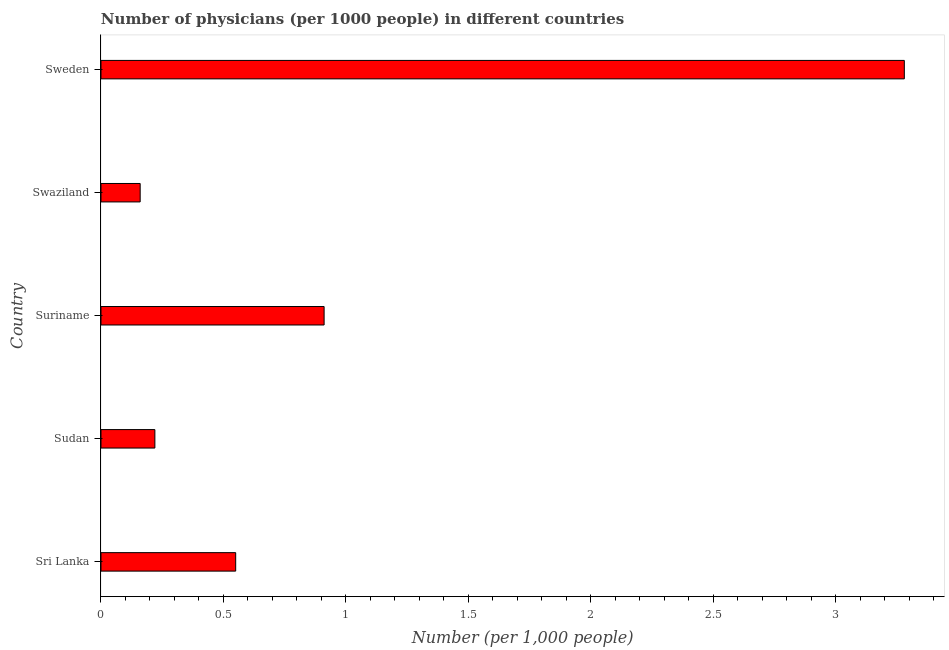What is the title of the graph?
Offer a very short reply. Number of physicians (per 1000 people) in different countries. What is the label or title of the X-axis?
Provide a succinct answer. Number (per 1,0 people). What is the label or title of the Y-axis?
Make the answer very short. Country. What is the number of physicians in Sudan?
Offer a very short reply. 0.22. Across all countries, what is the maximum number of physicians?
Your response must be concise. 3.28. Across all countries, what is the minimum number of physicians?
Your response must be concise. 0.16. In which country was the number of physicians minimum?
Your answer should be very brief. Swaziland. What is the sum of the number of physicians?
Give a very brief answer. 5.12. What is the difference between the number of physicians in Suriname and Sweden?
Ensure brevity in your answer.  -2.37. What is the median number of physicians?
Provide a short and direct response. 0.55. What is the ratio of the number of physicians in Suriname to that in Swaziland?
Your answer should be compact. 5.69. Is the number of physicians in Swaziland less than that in Sweden?
Your answer should be very brief. Yes. Is the difference between the number of physicians in Sri Lanka and Sweden greater than the difference between any two countries?
Give a very brief answer. No. What is the difference between the highest and the second highest number of physicians?
Your answer should be compact. 2.37. What is the difference between the highest and the lowest number of physicians?
Your response must be concise. 3.12. How many countries are there in the graph?
Your response must be concise. 5. What is the Number (per 1,000 people) of Sri Lanka?
Your answer should be compact. 0.55. What is the Number (per 1,000 people) of Sudan?
Give a very brief answer. 0.22. What is the Number (per 1,000 people) in Suriname?
Your response must be concise. 0.91. What is the Number (per 1,000 people) in Swaziland?
Make the answer very short. 0.16. What is the Number (per 1,000 people) in Sweden?
Give a very brief answer. 3.28. What is the difference between the Number (per 1,000 people) in Sri Lanka and Sudan?
Your answer should be compact. 0.33. What is the difference between the Number (per 1,000 people) in Sri Lanka and Suriname?
Offer a very short reply. -0.36. What is the difference between the Number (per 1,000 people) in Sri Lanka and Swaziland?
Provide a succinct answer. 0.39. What is the difference between the Number (per 1,000 people) in Sri Lanka and Sweden?
Your answer should be very brief. -2.73. What is the difference between the Number (per 1,000 people) in Sudan and Suriname?
Your answer should be very brief. -0.69. What is the difference between the Number (per 1,000 people) in Sudan and Sweden?
Your answer should be compact. -3.06. What is the difference between the Number (per 1,000 people) in Suriname and Swaziland?
Keep it short and to the point. 0.75. What is the difference between the Number (per 1,000 people) in Suriname and Sweden?
Keep it short and to the point. -2.37. What is the difference between the Number (per 1,000 people) in Swaziland and Sweden?
Your response must be concise. -3.12. What is the ratio of the Number (per 1,000 people) in Sri Lanka to that in Sudan?
Your response must be concise. 2.5. What is the ratio of the Number (per 1,000 people) in Sri Lanka to that in Suriname?
Your answer should be compact. 0.6. What is the ratio of the Number (per 1,000 people) in Sri Lanka to that in Swaziland?
Your answer should be very brief. 3.44. What is the ratio of the Number (per 1,000 people) in Sri Lanka to that in Sweden?
Give a very brief answer. 0.17. What is the ratio of the Number (per 1,000 people) in Sudan to that in Suriname?
Your response must be concise. 0.24. What is the ratio of the Number (per 1,000 people) in Sudan to that in Swaziland?
Ensure brevity in your answer.  1.38. What is the ratio of the Number (per 1,000 people) in Sudan to that in Sweden?
Your response must be concise. 0.07. What is the ratio of the Number (per 1,000 people) in Suriname to that in Swaziland?
Provide a succinct answer. 5.69. What is the ratio of the Number (per 1,000 people) in Suriname to that in Sweden?
Provide a short and direct response. 0.28. What is the ratio of the Number (per 1,000 people) in Swaziland to that in Sweden?
Offer a very short reply. 0.05. 